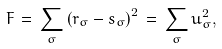Convert formula to latex. <formula><loc_0><loc_0><loc_500><loc_500>F \, = \, \sum _ { \sigma } \left ( { r } _ { \sigma } - { s } _ { \sigma } \right ) ^ { 2 } \, = \, \sum _ { \sigma } { u } _ { \sigma } ^ { 2 } ,</formula> 